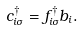Convert formula to latex. <formula><loc_0><loc_0><loc_500><loc_500>c ^ { \dagger } _ { i \sigma } = f ^ { \dagger } _ { i \sigma } b _ { i } .</formula> 